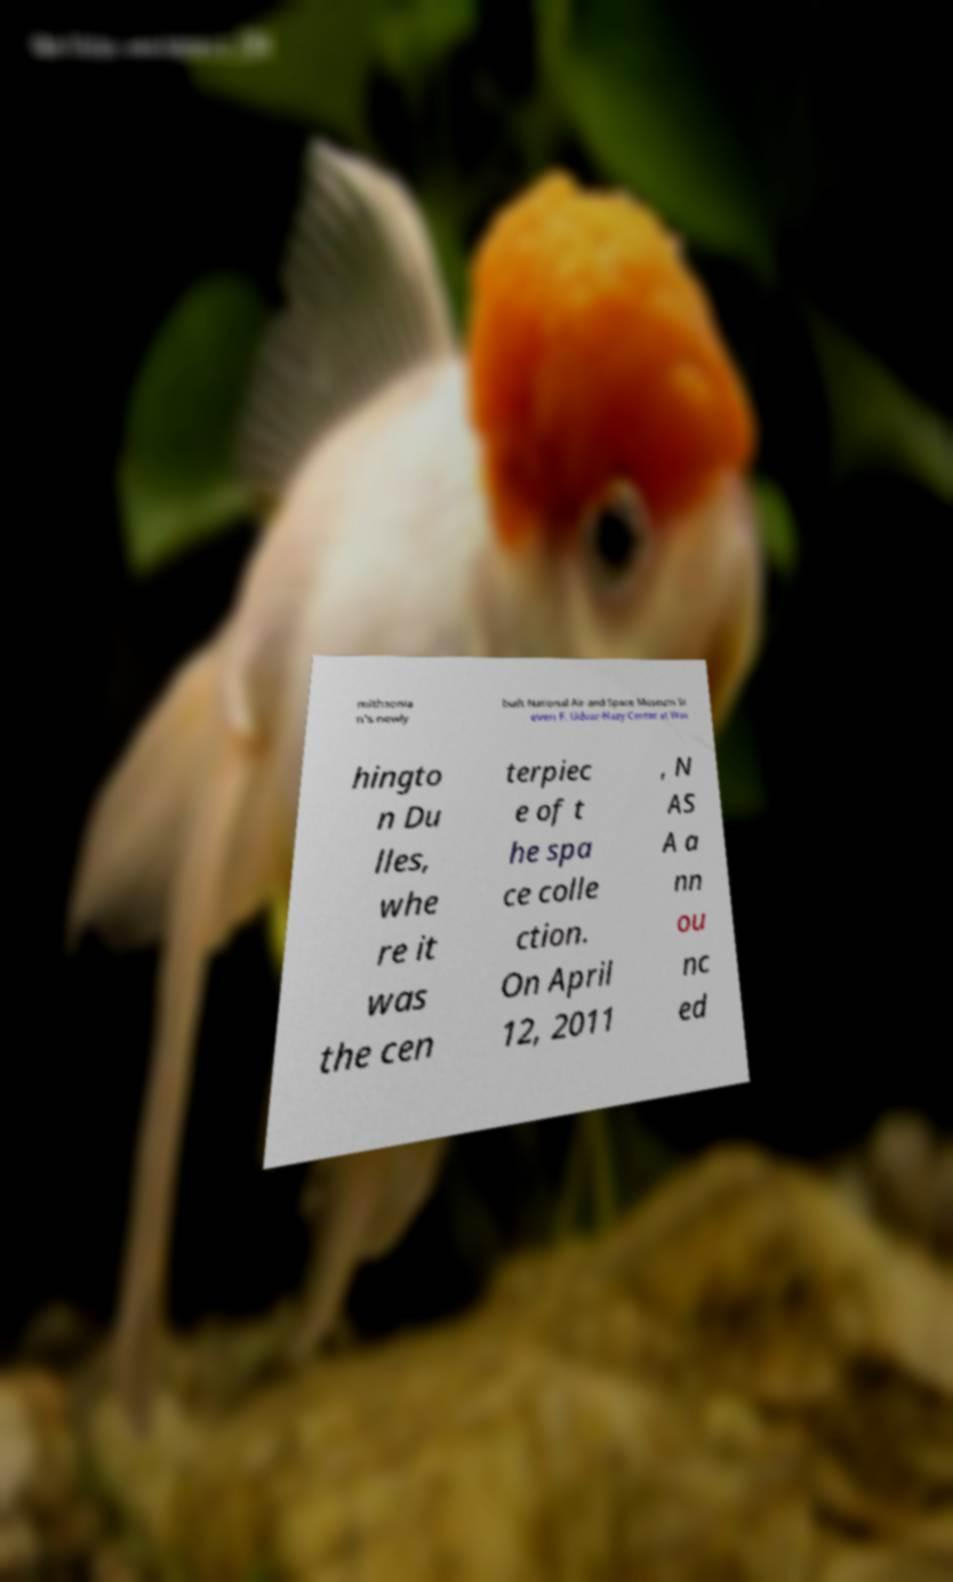Please read and relay the text visible in this image. What does it say? mithsonia n's newly built National Air and Space Museum St even F. Udvar-Hazy Center at Was hingto n Du lles, whe re it was the cen terpiec e of t he spa ce colle ction. On April 12, 2011 , N AS A a nn ou nc ed 